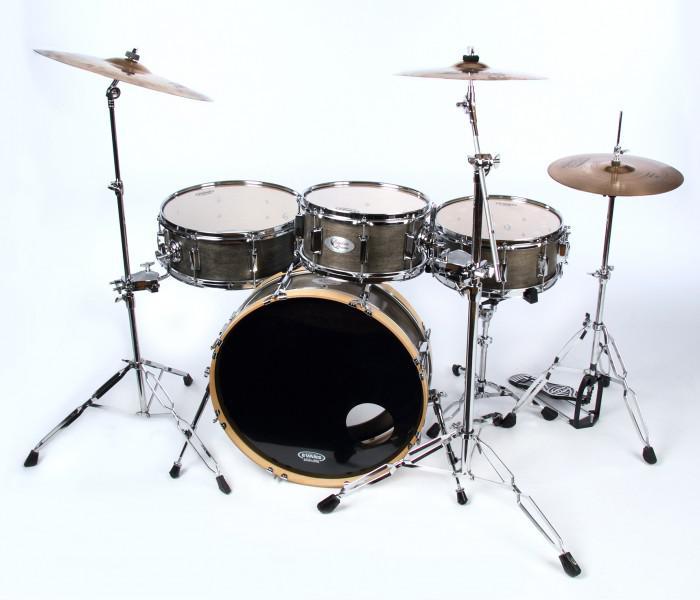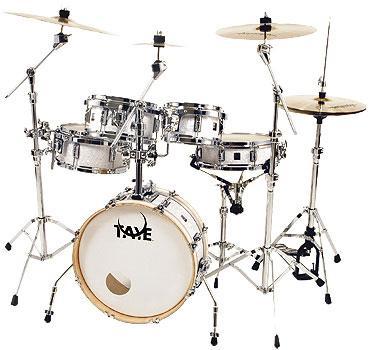The first image is the image on the left, the second image is the image on the right. Given the left and right images, does the statement "Each image features a drum kit with exactly one large drum that has a white side facing outwards and is positioned between cymbals on stands." hold true? Answer yes or no. No. 